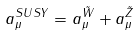Convert formula to latex. <formula><loc_0><loc_0><loc_500><loc_500>a _ { \mu } ^ { S U S Y } = { a _ { \mu } ^ { \tilde { W } } + a _ { \mu } ^ { \tilde { Z } } }</formula> 